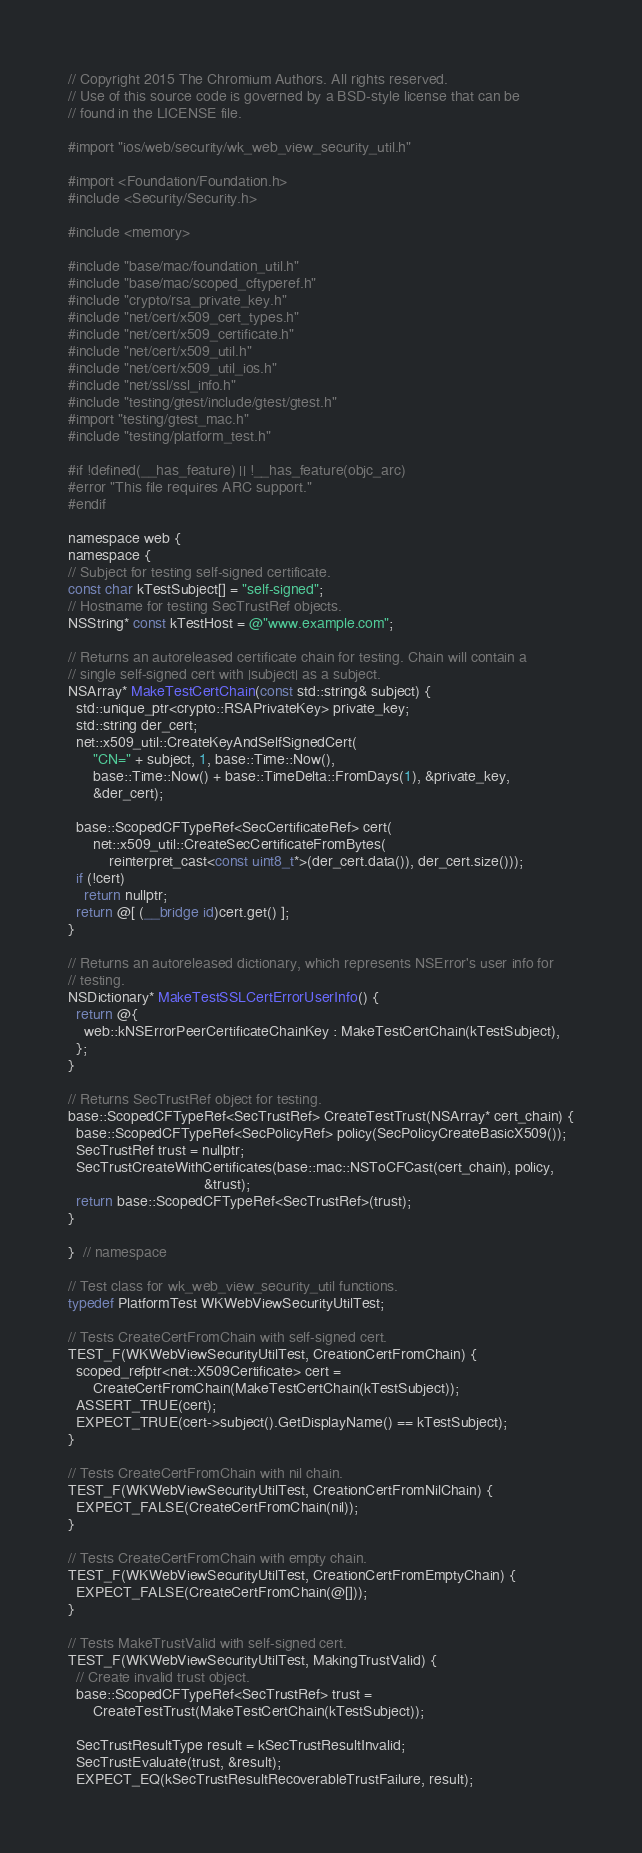<code> <loc_0><loc_0><loc_500><loc_500><_ObjectiveC_>// Copyright 2015 The Chromium Authors. All rights reserved.
// Use of this source code is governed by a BSD-style license that can be
// found in the LICENSE file.

#import "ios/web/security/wk_web_view_security_util.h"

#import <Foundation/Foundation.h>
#include <Security/Security.h>

#include <memory>

#include "base/mac/foundation_util.h"
#include "base/mac/scoped_cftyperef.h"
#include "crypto/rsa_private_key.h"
#include "net/cert/x509_cert_types.h"
#include "net/cert/x509_certificate.h"
#include "net/cert/x509_util.h"
#include "net/cert/x509_util_ios.h"
#include "net/ssl/ssl_info.h"
#include "testing/gtest/include/gtest/gtest.h"
#import "testing/gtest_mac.h"
#include "testing/platform_test.h"

#if !defined(__has_feature) || !__has_feature(objc_arc)
#error "This file requires ARC support."
#endif

namespace web {
namespace {
// Subject for testing self-signed certificate.
const char kTestSubject[] = "self-signed";
// Hostname for testing SecTrustRef objects.
NSString* const kTestHost = @"www.example.com";

// Returns an autoreleased certificate chain for testing. Chain will contain a
// single self-signed cert with |subject| as a subject.
NSArray* MakeTestCertChain(const std::string& subject) {
  std::unique_ptr<crypto::RSAPrivateKey> private_key;
  std::string der_cert;
  net::x509_util::CreateKeyAndSelfSignedCert(
      "CN=" + subject, 1, base::Time::Now(),
      base::Time::Now() + base::TimeDelta::FromDays(1), &private_key,
      &der_cert);

  base::ScopedCFTypeRef<SecCertificateRef> cert(
      net::x509_util::CreateSecCertificateFromBytes(
          reinterpret_cast<const uint8_t*>(der_cert.data()), der_cert.size()));
  if (!cert)
    return nullptr;
  return @[ (__bridge id)cert.get() ];
}

// Returns an autoreleased dictionary, which represents NSError's user info for
// testing.
NSDictionary* MakeTestSSLCertErrorUserInfo() {
  return @{
    web::kNSErrorPeerCertificateChainKey : MakeTestCertChain(kTestSubject),
  };
}

// Returns SecTrustRef object for testing.
base::ScopedCFTypeRef<SecTrustRef> CreateTestTrust(NSArray* cert_chain) {
  base::ScopedCFTypeRef<SecPolicyRef> policy(SecPolicyCreateBasicX509());
  SecTrustRef trust = nullptr;
  SecTrustCreateWithCertificates(base::mac::NSToCFCast(cert_chain), policy,
                                 &trust);
  return base::ScopedCFTypeRef<SecTrustRef>(trust);
}

}  // namespace

// Test class for wk_web_view_security_util functions.
typedef PlatformTest WKWebViewSecurityUtilTest;

// Tests CreateCertFromChain with self-signed cert.
TEST_F(WKWebViewSecurityUtilTest, CreationCertFromChain) {
  scoped_refptr<net::X509Certificate> cert =
      CreateCertFromChain(MakeTestCertChain(kTestSubject));
  ASSERT_TRUE(cert);
  EXPECT_TRUE(cert->subject().GetDisplayName() == kTestSubject);
}

// Tests CreateCertFromChain with nil chain.
TEST_F(WKWebViewSecurityUtilTest, CreationCertFromNilChain) {
  EXPECT_FALSE(CreateCertFromChain(nil));
}

// Tests CreateCertFromChain with empty chain.
TEST_F(WKWebViewSecurityUtilTest, CreationCertFromEmptyChain) {
  EXPECT_FALSE(CreateCertFromChain(@[]));
}

// Tests MakeTrustValid with self-signed cert.
TEST_F(WKWebViewSecurityUtilTest, MakingTrustValid) {
  // Create invalid trust object.
  base::ScopedCFTypeRef<SecTrustRef> trust =
      CreateTestTrust(MakeTestCertChain(kTestSubject));

  SecTrustResultType result = kSecTrustResultInvalid;
  SecTrustEvaluate(trust, &result);
  EXPECT_EQ(kSecTrustResultRecoverableTrustFailure, result);
</code> 